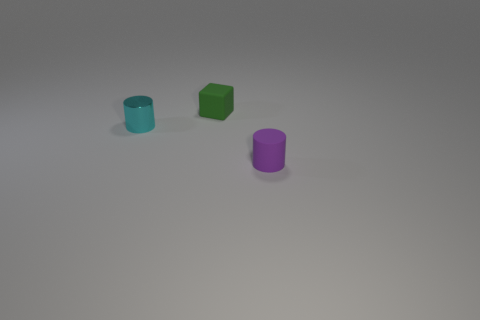There is a matte object on the right side of the small object behind the tiny cyan metal object; what number of green objects are in front of it?
Provide a succinct answer. 0. Is the number of big red metal cylinders less than the number of green cubes?
Your answer should be compact. Yes. There is a tiny cyan shiny thing behind the purple rubber cylinder; does it have the same shape as the object that is behind the cyan shiny object?
Provide a short and direct response. No. What is the color of the small matte block?
Keep it short and to the point. Green. What number of shiny things are small purple things or tiny things?
Provide a succinct answer. 1. What is the color of the other small rubber thing that is the same shape as the small cyan object?
Give a very brief answer. Purple. Are there any small rubber spheres?
Provide a short and direct response. No. Are the small cylinder behind the tiny purple cylinder and the small cylinder that is to the right of the green matte block made of the same material?
Provide a short and direct response. No. What number of things are either tiny things that are on the right side of the tiny green cube or small rubber things that are behind the shiny object?
Provide a short and direct response. 2. Do the rubber object in front of the small cyan object and the small matte object that is behind the metal cylinder have the same color?
Offer a terse response. No. 